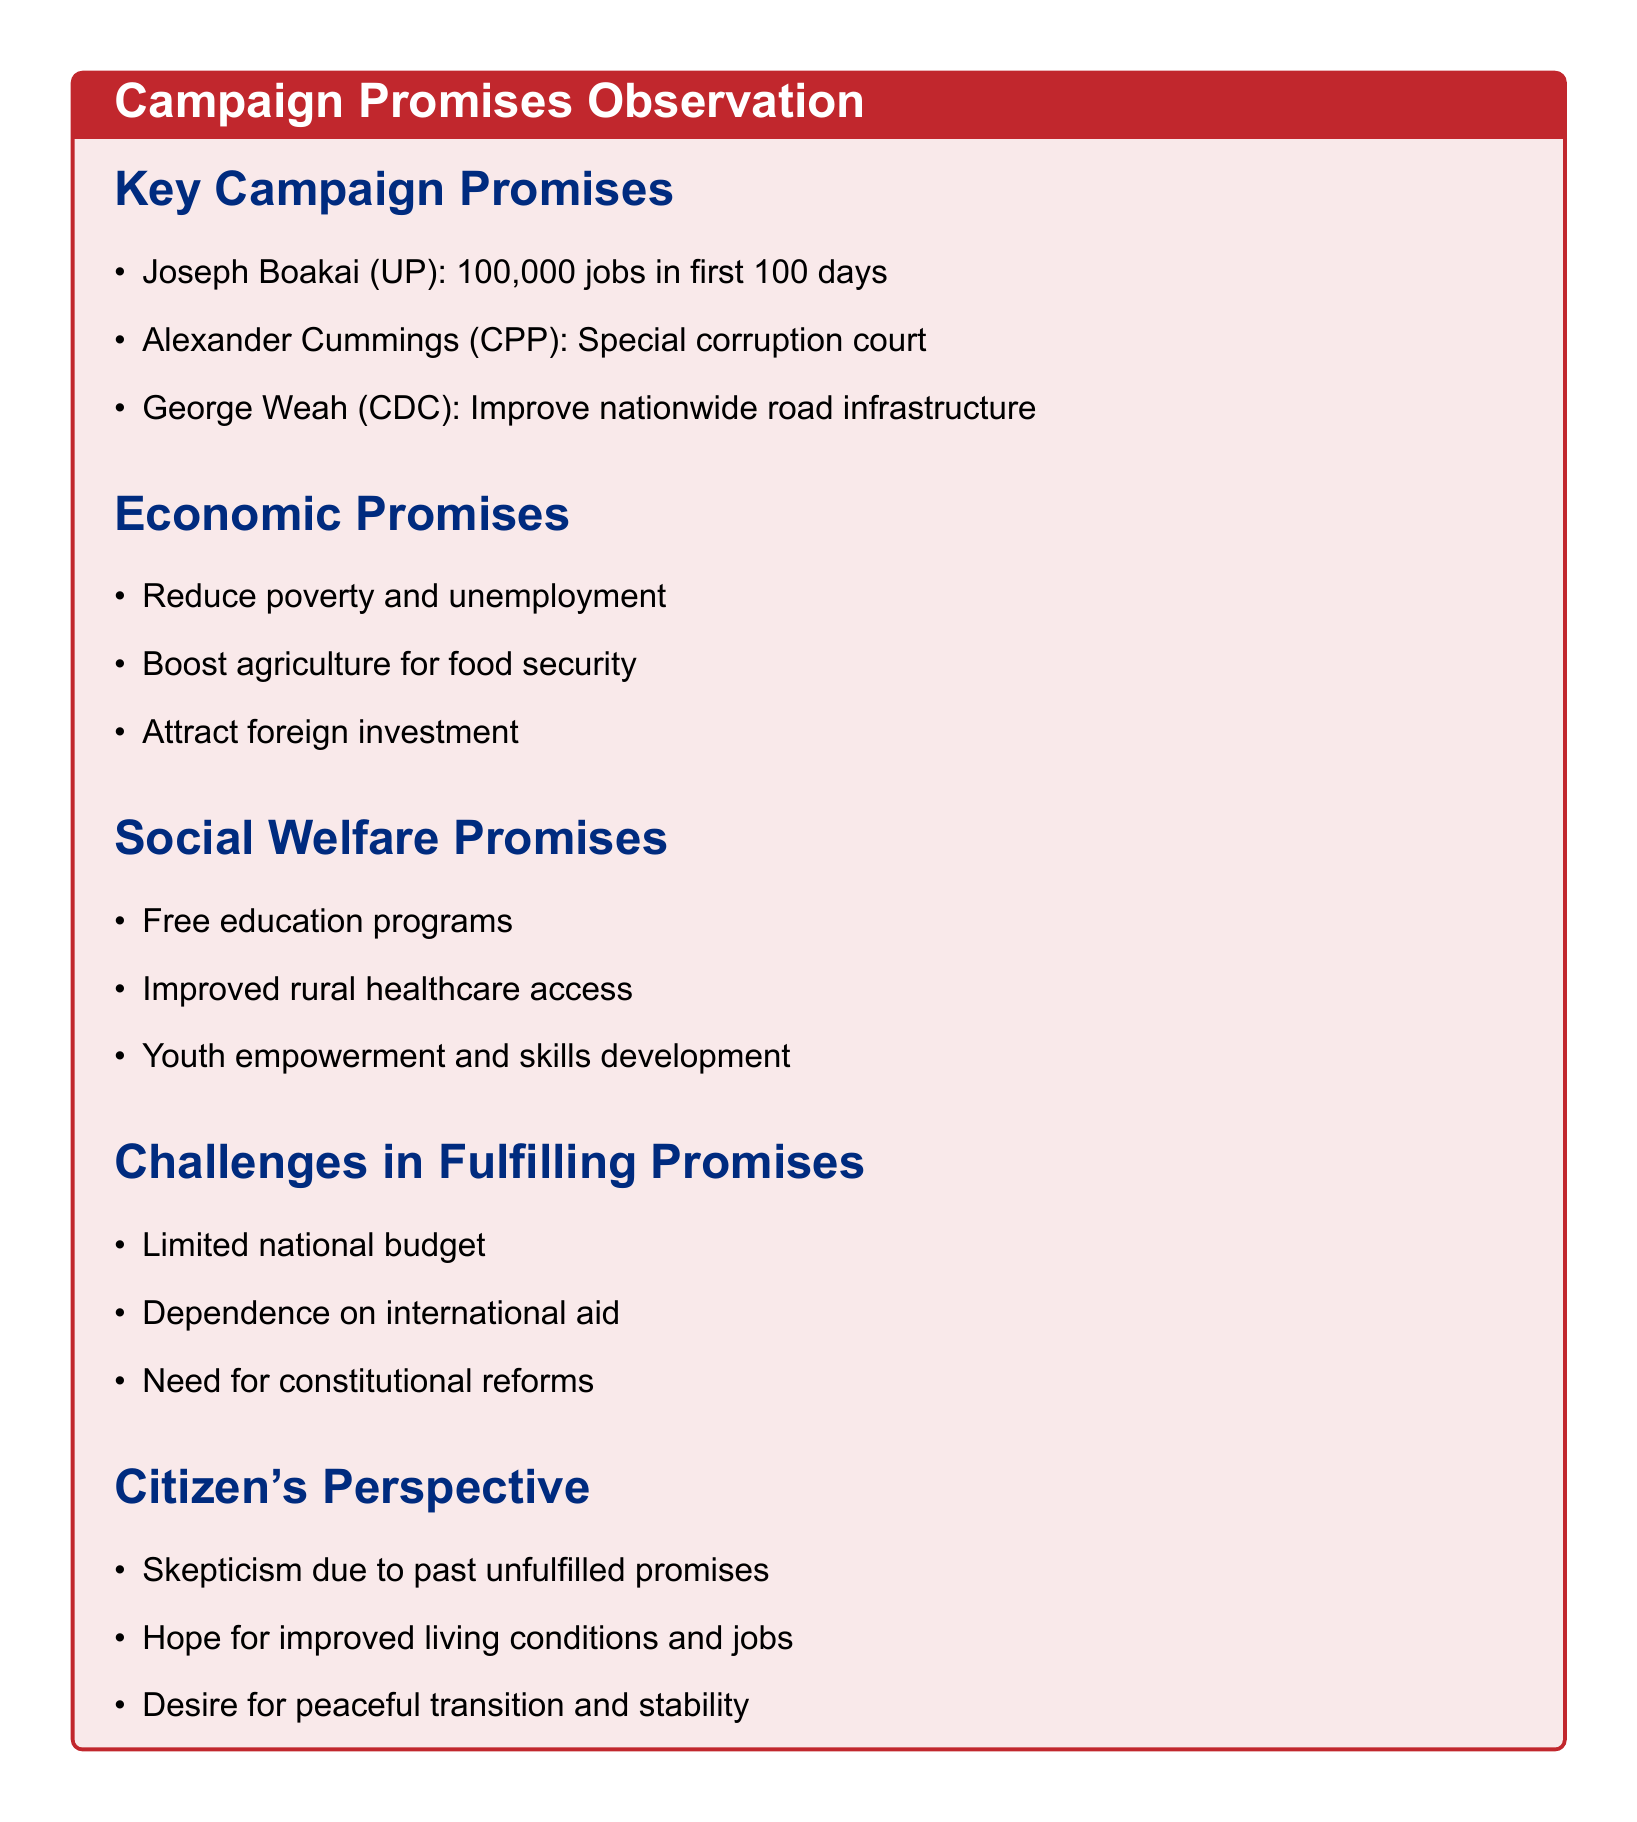What is Joseph Boakai's job creation pledge? Joseph Boakai pledged to create 100,000 jobs in the first 100 days.
Answer: 100,000 jobs What type of court did Alexander Cummings promise to establish? Alexander Cummings promised to establish a special corruption court.
Answer: Special corruption court Which candidate vowed to improve road infrastructure? George Weah vowed to improve road infrastructure nationwide.
Answer: George Weah What economic focus is common among most candidates? Most candidates focused on reducing poverty and unemployment.
Answer: Reducing poverty and unemployment What social welfare program was proposed by multiple candidates? Free education programs were proposed by multiple candidates.
Answer: Free education programs What challenge might affect the fulfillment of promises? Limited national budget constrains implementation of ambitious projects.
Answer: Limited national budget What is a citizen's concern based on past experiences? Skepticism due to unfulfilled promises from previous elections.
Answer: Skepticism What is a hope expressed by citizens regarding the elections? Hope for improved living conditions and job opportunities.
Answer: Improved living conditions and job opportunities 